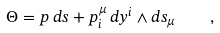Convert formula to latex. <formula><loc_0><loc_0><loc_500><loc_500>\Theta = p \, d s + p ^ { \mu } _ { i } \, d y ^ { i } \wedge d s _ { \mu } \quad ,</formula> 